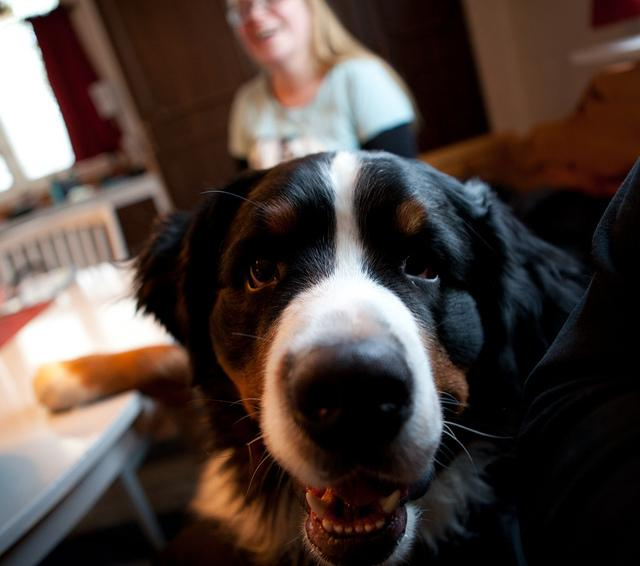What are they looking at?

Choices:
A) photographer
B) dog
C) walls
D) table photographer 